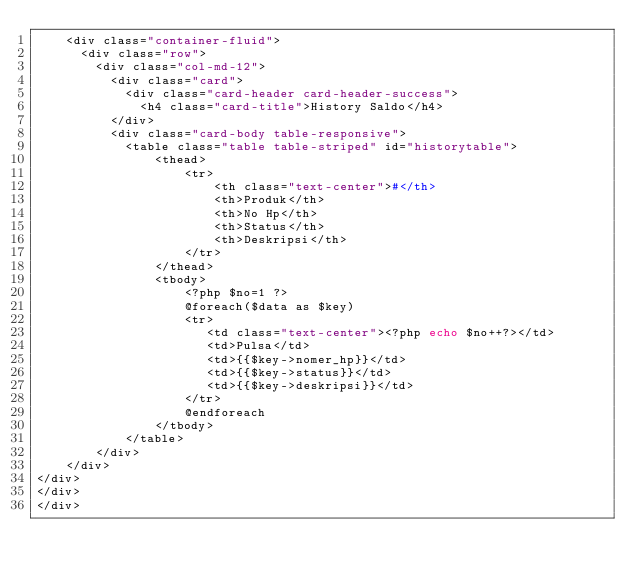Convert code to text. <code><loc_0><loc_0><loc_500><loc_500><_PHP_>    <div class="container-fluid">
      <div class="row">
        <div class="col-md-12">
          <div class="card">
            <div class="card-header card-header-success">
              <h4 class="card-title">History Saldo</h4>
          </div>
          <div class="card-body table-responsive">
            <table class="table table-striped" id="historytable">
                <thead>
                    <tr>
                        <th class="text-center">#</th>
                        <th>Produk</th>
                        <th>No Hp</th>
                        <th>Status</th>
                        <th>Deskripsi</th>
                    </tr>
                </thead>
                <tbody>
                    <?php $no=1 ?>
                    @foreach($data as $key)
                    <tr>    
                       <td class="text-center"><?php echo $no++?></td>
                       <td>Pulsa</td>
                       <td>{{$key->nomer_hp}}</td>
                       <td>{{$key->status}}</td>
                       <td>{{$key->deskripsi}}</td>
                    </tr>
                    @endforeach
                </tbody>
            </table>
        </div>
    </div>
</div>
</div>
</div></code> 